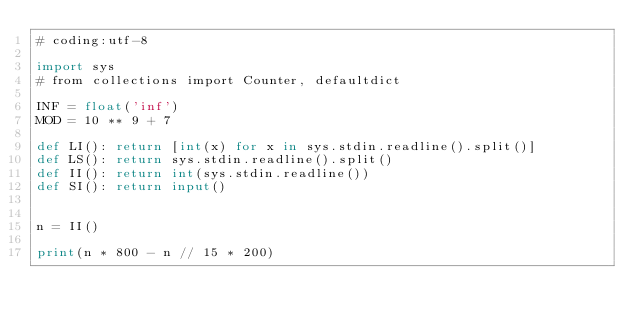Convert code to text. <code><loc_0><loc_0><loc_500><loc_500><_Python_># coding:utf-8

import sys
# from collections import Counter, defaultdict

INF = float('inf')
MOD = 10 ** 9 + 7

def LI(): return [int(x) for x in sys.stdin.readline().split()]
def LS(): return sys.stdin.readline().split()
def II(): return int(sys.stdin.readline())
def SI(): return input()


n = II()

print(n * 800 - n // 15 * 200)
</code> 